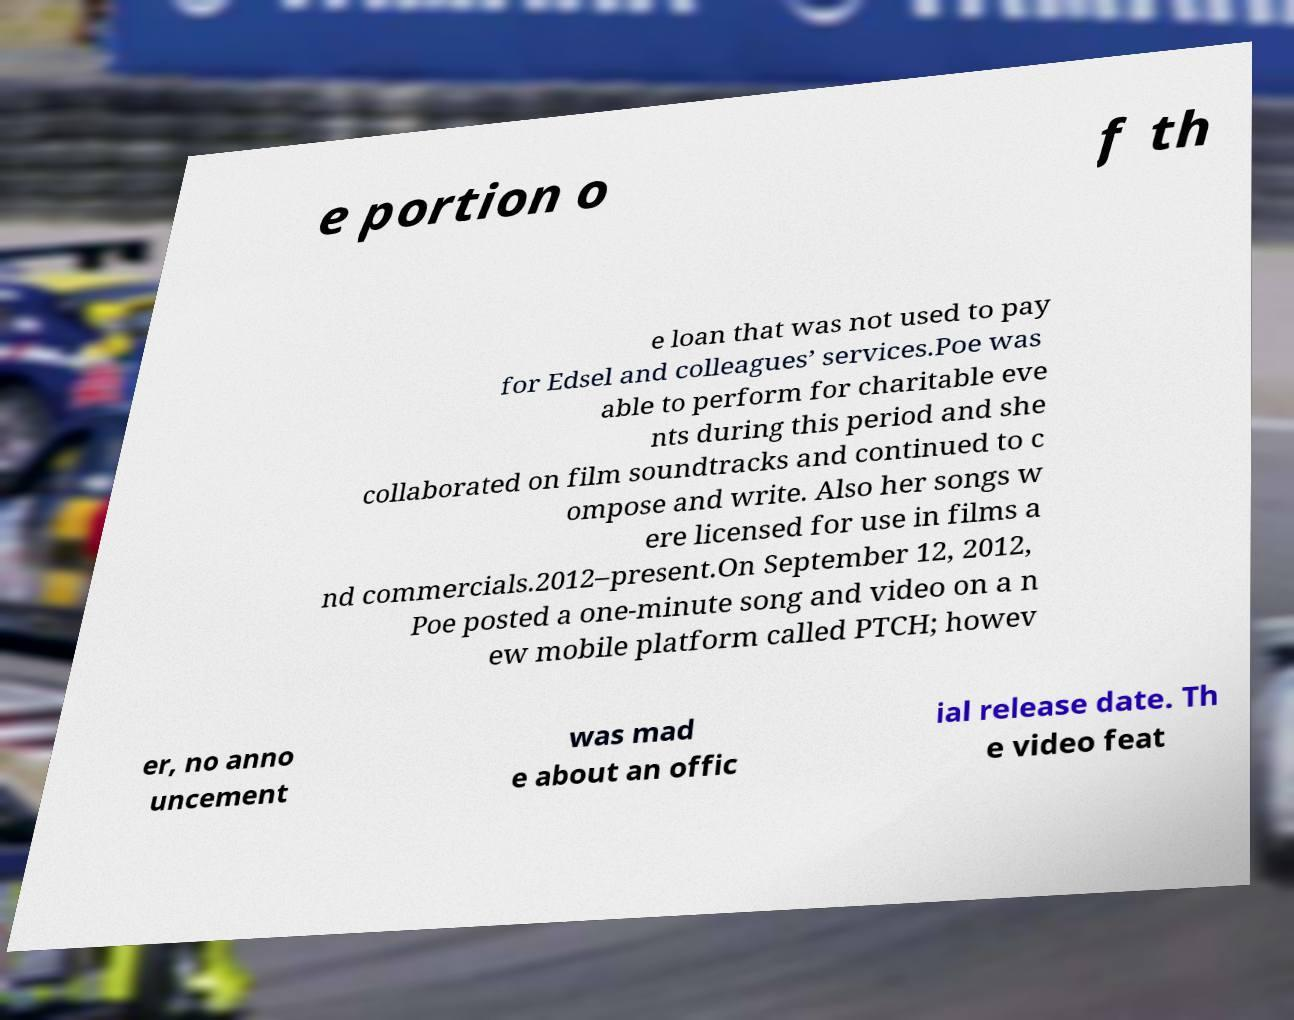Could you assist in decoding the text presented in this image and type it out clearly? e portion o f th e loan that was not used to pay for Edsel and colleagues’ services.Poe was able to perform for charitable eve nts during this period and she collaborated on film soundtracks and continued to c ompose and write. Also her songs w ere licensed for use in films a nd commercials.2012–present.On September 12, 2012, Poe posted a one-minute song and video on a n ew mobile platform called PTCH; howev er, no anno uncement was mad e about an offic ial release date. Th e video feat 